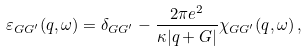Convert formula to latex. <formula><loc_0><loc_0><loc_500><loc_500>\varepsilon _ { G G ^ { \prime } } ( q , \omega ) = \delta _ { G G ^ { \prime } } - \frac { 2 \pi e ^ { 2 } } { \kappa | q + G | } \chi _ { G G ^ { \prime } } ( q , \omega ) \, ,</formula> 